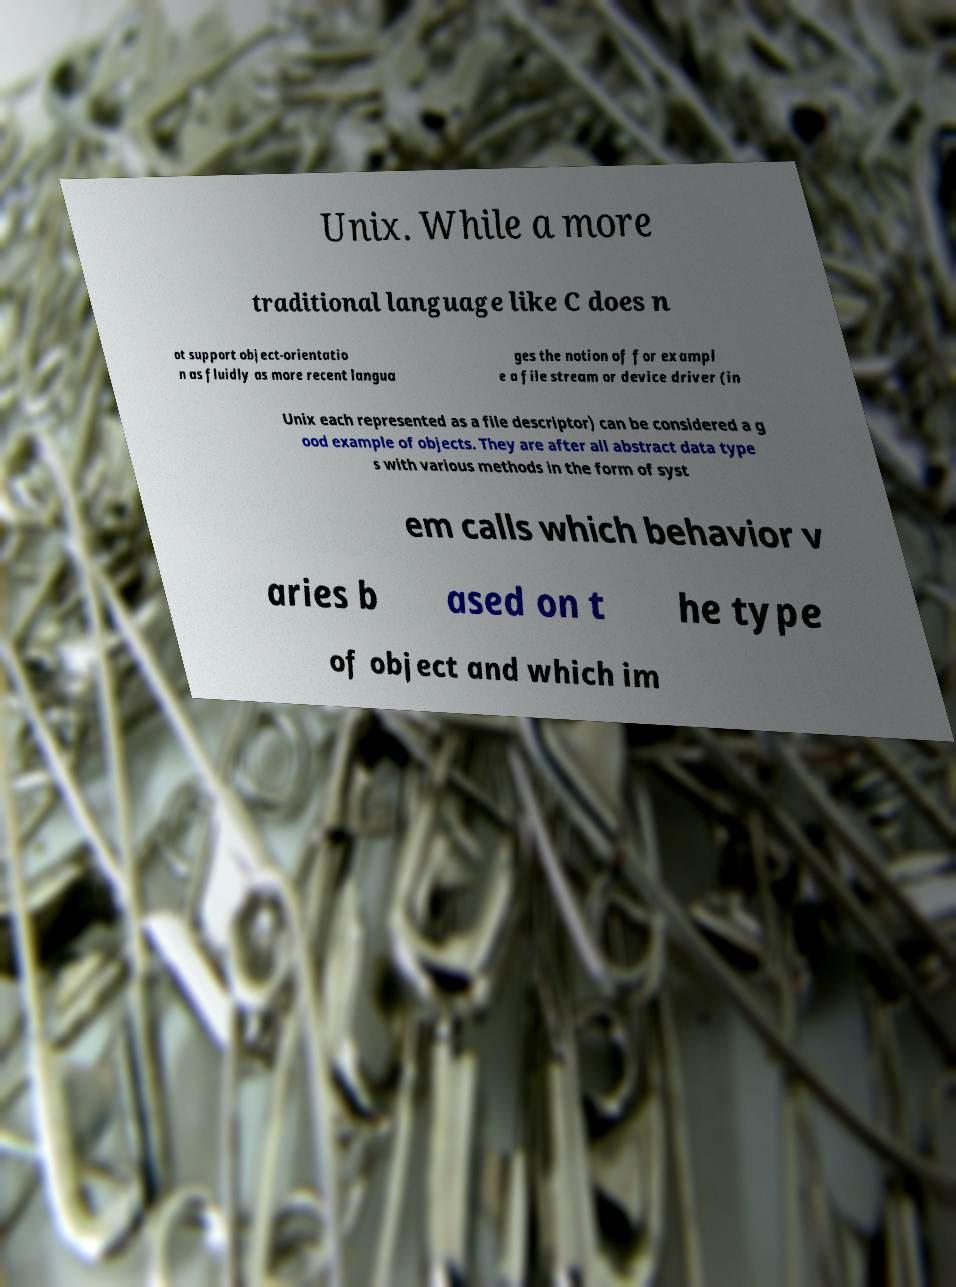Can you accurately transcribe the text from the provided image for me? Unix. While a more traditional language like C does n ot support object-orientatio n as fluidly as more recent langua ges the notion of for exampl e a file stream or device driver (in Unix each represented as a file descriptor) can be considered a g ood example of objects. They are after all abstract data type s with various methods in the form of syst em calls which behavior v aries b ased on t he type of object and which im 